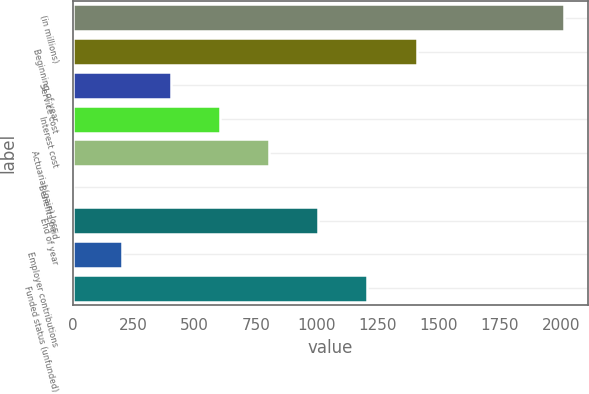Convert chart. <chart><loc_0><loc_0><loc_500><loc_500><bar_chart><fcel>(in millions)<fcel>Beginning of year<fcel>Service cost<fcel>Interest cost<fcel>Actuarial (gain) loss<fcel>Benefits paid<fcel>End of year<fcel>Employer contributions<fcel>Funded status (unfunded)<nl><fcel>2011<fcel>1408.48<fcel>404.28<fcel>605.12<fcel>805.96<fcel>2.6<fcel>1006.8<fcel>203.44<fcel>1207.64<nl></chart> 